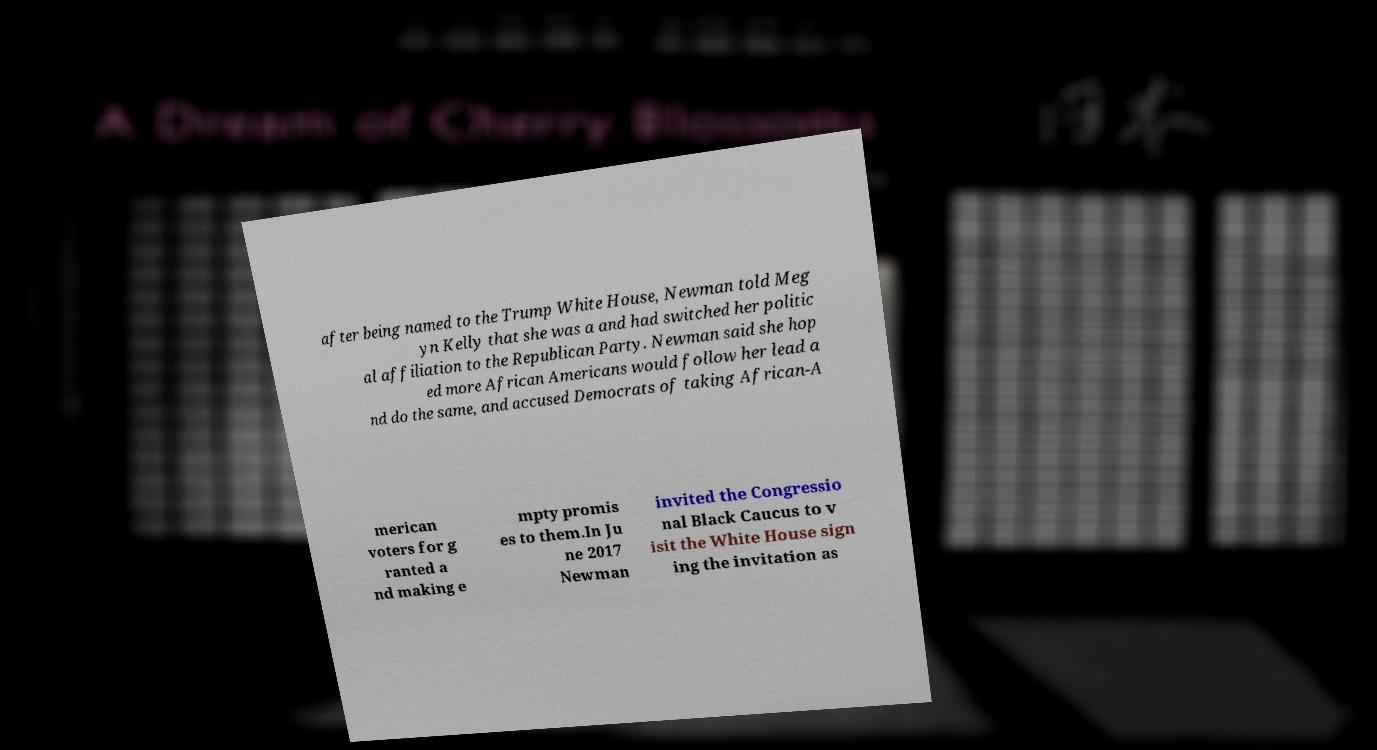Could you extract and type out the text from this image? after being named to the Trump White House, Newman told Meg yn Kelly that she was a and had switched her politic al affiliation to the Republican Party. Newman said she hop ed more African Americans would follow her lead a nd do the same, and accused Democrats of taking African-A merican voters for g ranted a nd making e mpty promis es to them.In Ju ne 2017 Newman invited the Congressio nal Black Caucus to v isit the White House sign ing the invitation as 